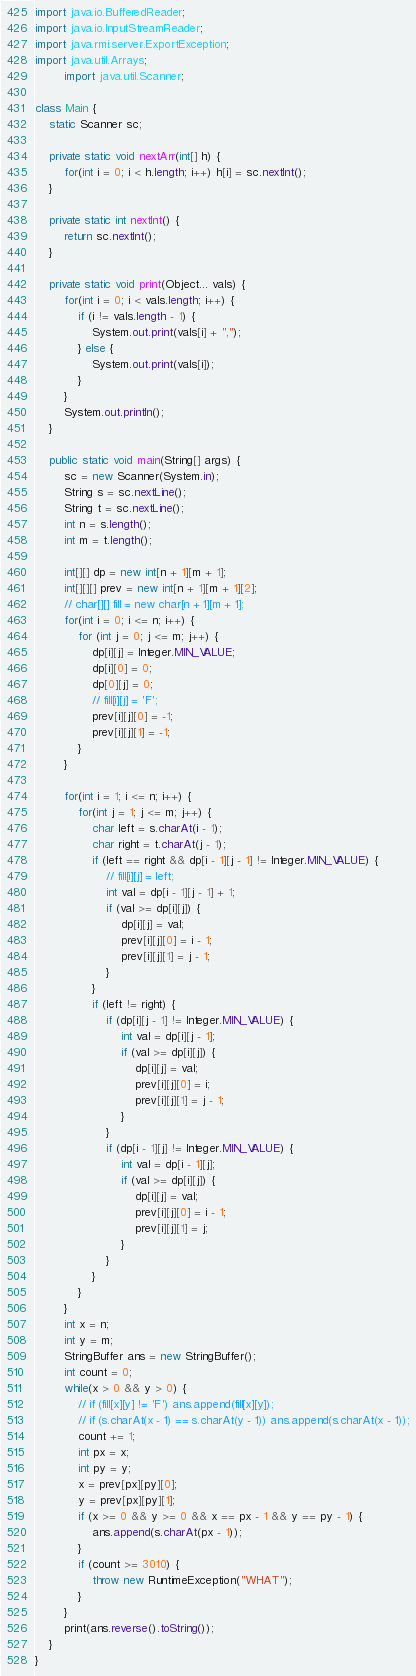<code> <loc_0><loc_0><loc_500><loc_500><_Java_>import java.io.BufferedReader;
import java.io.InputStreamReader;
import java.rmi.server.ExportException;
import java.util.Arrays;
        import java.util.Scanner;

class Main {
    static Scanner sc;

    private static void nextArr(int[] h) {
        for(int i = 0; i < h.length; i++) h[i] = sc.nextInt();
    }

    private static int nextInt() {
        return sc.nextInt();
    }

    private static void print(Object... vals) {
        for(int i = 0; i < vals.length; i++) {
            if (i != vals.length - 1) {
                System.out.print(vals[i] + ",");
            } else {
                System.out.print(vals[i]);
            }
        }
        System.out.println();
    }

    public static void main(String[] args) {
        sc = new Scanner(System.in);
        String s = sc.nextLine();
        String t = sc.nextLine();
        int n = s.length();
        int m = t.length();

        int[][] dp = new int[n + 1][m + 1];
        int[][][] prev = new int[n + 1][m + 1][2];
        // char[][] fill = new char[n + 1][m + 1];
        for(int i = 0; i <= n; i++) {
            for (int j = 0; j <= m; j++) {
                dp[i][j] = Integer.MIN_VALUE;
                dp[i][0] = 0;
                dp[0][j] = 0;
                // fill[i][j] = 'F';
                prev[i][j][0] = -1;
                prev[i][j][1] = -1;
            }
        }

        for(int i = 1; i <= n; i++) {
            for(int j = 1; j <= m; j++) {
                char left = s.charAt(i - 1);
                char right = t.charAt(j - 1);
                if (left == right && dp[i - 1][j - 1] != Integer.MIN_VALUE) {
                    // fill[i][j] = left;
                    int val = dp[i - 1][j - 1] + 1;
                    if (val >= dp[i][j]) {
                        dp[i][j] = val;
                        prev[i][j][0] = i - 1;
                        prev[i][j][1] = j - 1;
                    }
                }
                if (left != right) {
                    if (dp[i][j - 1] != Integer.MIN_VALUE) {
                        int val = dp[i][j - 1];
                        if (val >= dp[i][j]) {
                            dp[i][j] = val;
                            prev[i][j][0] = i;
                            prev[i][j][1] = j - 1;
                        }
                    }
                    if (dp[i - 1][j] != Integer.MIN_VALUE) {
                        int val = dp[i - 1][j];
                        if (val >= dp[i][j]) {
                            dp[i][j] = val;
                            prev[i][j][0] = i - 1;
                            prev[i][j][1] = j;
                        }
                    }
                }
            }
        }
        int x = n;
        int y = m;
        StringBuffer ans = new StringBuffer();
        int count = 0;
        while(x > 0 && y > 0) {
            // if (fill[x][y] != 'F') ans.append(fill[x][y]);
            // if (s.charAt(x - 1) == s.charAt(y - 1)) ans.append(s.charAt(x - 1));
            count += 1;
            int px = x;
            int py = y;
            x = prev[px][py][0];
            y = prev[px][py][1];
            if (x >= 0 && y >= 0 && x == px - 1 && y == py - 1) {
                ans.append(s.charAt(px - 1));
            }
            if (count >= 3010) {
                throw new RuntimeException("WHAT");
            }
        }
        print(ans.reverse().toString());
    }
}
</code> 